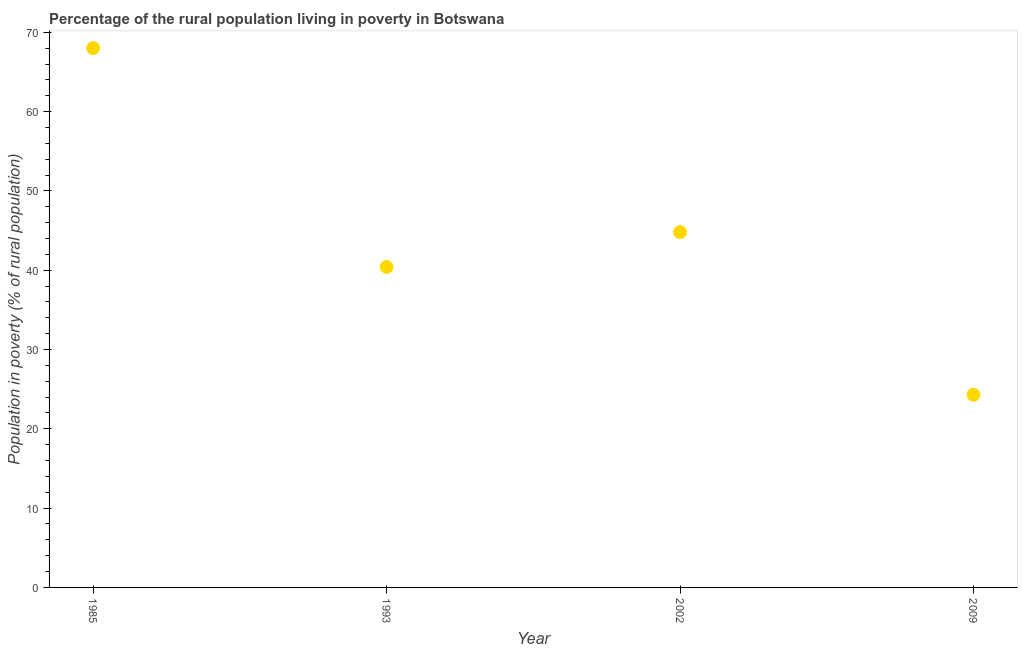What is the percentage of rural population living below poverty line in 1993?
Give a very brief answer. 40.4. Across all years, what is the minimum percentage of rural population living below poverty line?
Ensure brevity in your answer.  24.3. In which year was the percentage of rural population living below poverty line maximum?
Ensure brevity in your answer.  1985. In which year was the percentage of rural population living below poverty line minimum?
Provide a short and direct response. 2009. What is the sum of the percentage of rural population living below poverty line?
Keep it short and to the point. 177.5. What is the difference between the percentage of rural population living below poverty line in 1993 and 2002?
Keep it short and to the point. -4.4. What is the average percentage of rural population living below poverty line per year?
Offer a terse response. 44.38. What is the median percentage of rural population living below poverty line?
Your answer should be compact. 42.6. What is the ratio of the percentage of rural population living below poverty line in 1993 to that in 2009?
Offer a very short reply. 1.66. Is the percentage of rural population living below poverty line in 1985 less than that in 1993?
Keep it short and to the point. No. What is the difference between the highest and the second highest percentage of rural population living below poverty line?
Your response must be concise. 23.2. Is the sum of the percentage of rural population living below poverty line in 1993 and 2009 greater than the maximum percentage of rural population living below poverty line across all years?
Provide a succinct answer. No. What is the difference between the highest and the lowest percentage of rural population living below poverty line?
Provide a succinct answer. 43.7. In how many years, is the percentage of rural population living below poverty line greater than the average percentage of rural population living below poverty line taken over all years?
Your response must be concise. 2. How many dotlines are there?
Make the answer very short. 1. How many years are there in the graph?
Your response must be concise. 4. Are the values on the major ticks of Y-axis written in scientific E-notation?
Offer a terse response. No. Does the graph contain grids?
Your answer should be compact. No. What is the title of the graph?
Make the answer very short. Percentage of the rural population living in poverty in Botswana. What is the label or title of the Y-axis?
Your answer should be very brief. Population in poverty (% of rural population). What is the Population in poverty (% of rural population) in 1993?
Offer a terse response. 40.4. What is the Population in poverty (% of rural population) in 2002?
Make the answer very short. 44.8. What is the Population in poverty (% of rural population) in 2009?
Your answer should be very brief. 24.3. What is the difference between the Population in poverty (% of rural population) in 1985 and 1993?
Provide a succinct answer. 27.6. What is the difference between the Population in poverty (% of rural population) in 1985 and 2002?
Keep it short and to the point. 23.2. What is the difference between the Population in poverty (% of rural population) in 1985 and 2009?
Give a very brief answer. 43.7. What is the difference between the Population in poverty (% of rural population) in 1993 and 2002?
Your answer should be compact. -4.4. What is the difference between the Population in poverty (% of rural population) in 1993 and 2009?
Your answer should be very brief. 16.1. What is the ratio of the Population in poverty (% of rural population) in 1985 to that in 1993?
Your answer should be very brief. 1.68. What is the ratio of the Population in poverty (% of rural population) in 1985 to that in 2002?
Ensure brevity in your answer.  1.52. What is the ratio of the Population in poverty (% of rural population) in 1985 to that in 2009?
Your answer should be very brief. 2.8. What is the ratio of the Population in poverty (% of rural population) in 1993 to that in 2002?
Make the answer very short. 0.9. What is the ratio of the Population in poverty (% of rural population) in 1993 to that in 2009?
Make the answer very short. 1.66. What is the ratio of the Population in poverty (% of rural population) in 2002 to that in 2009?
Keep it short and to the point. 1.84. 